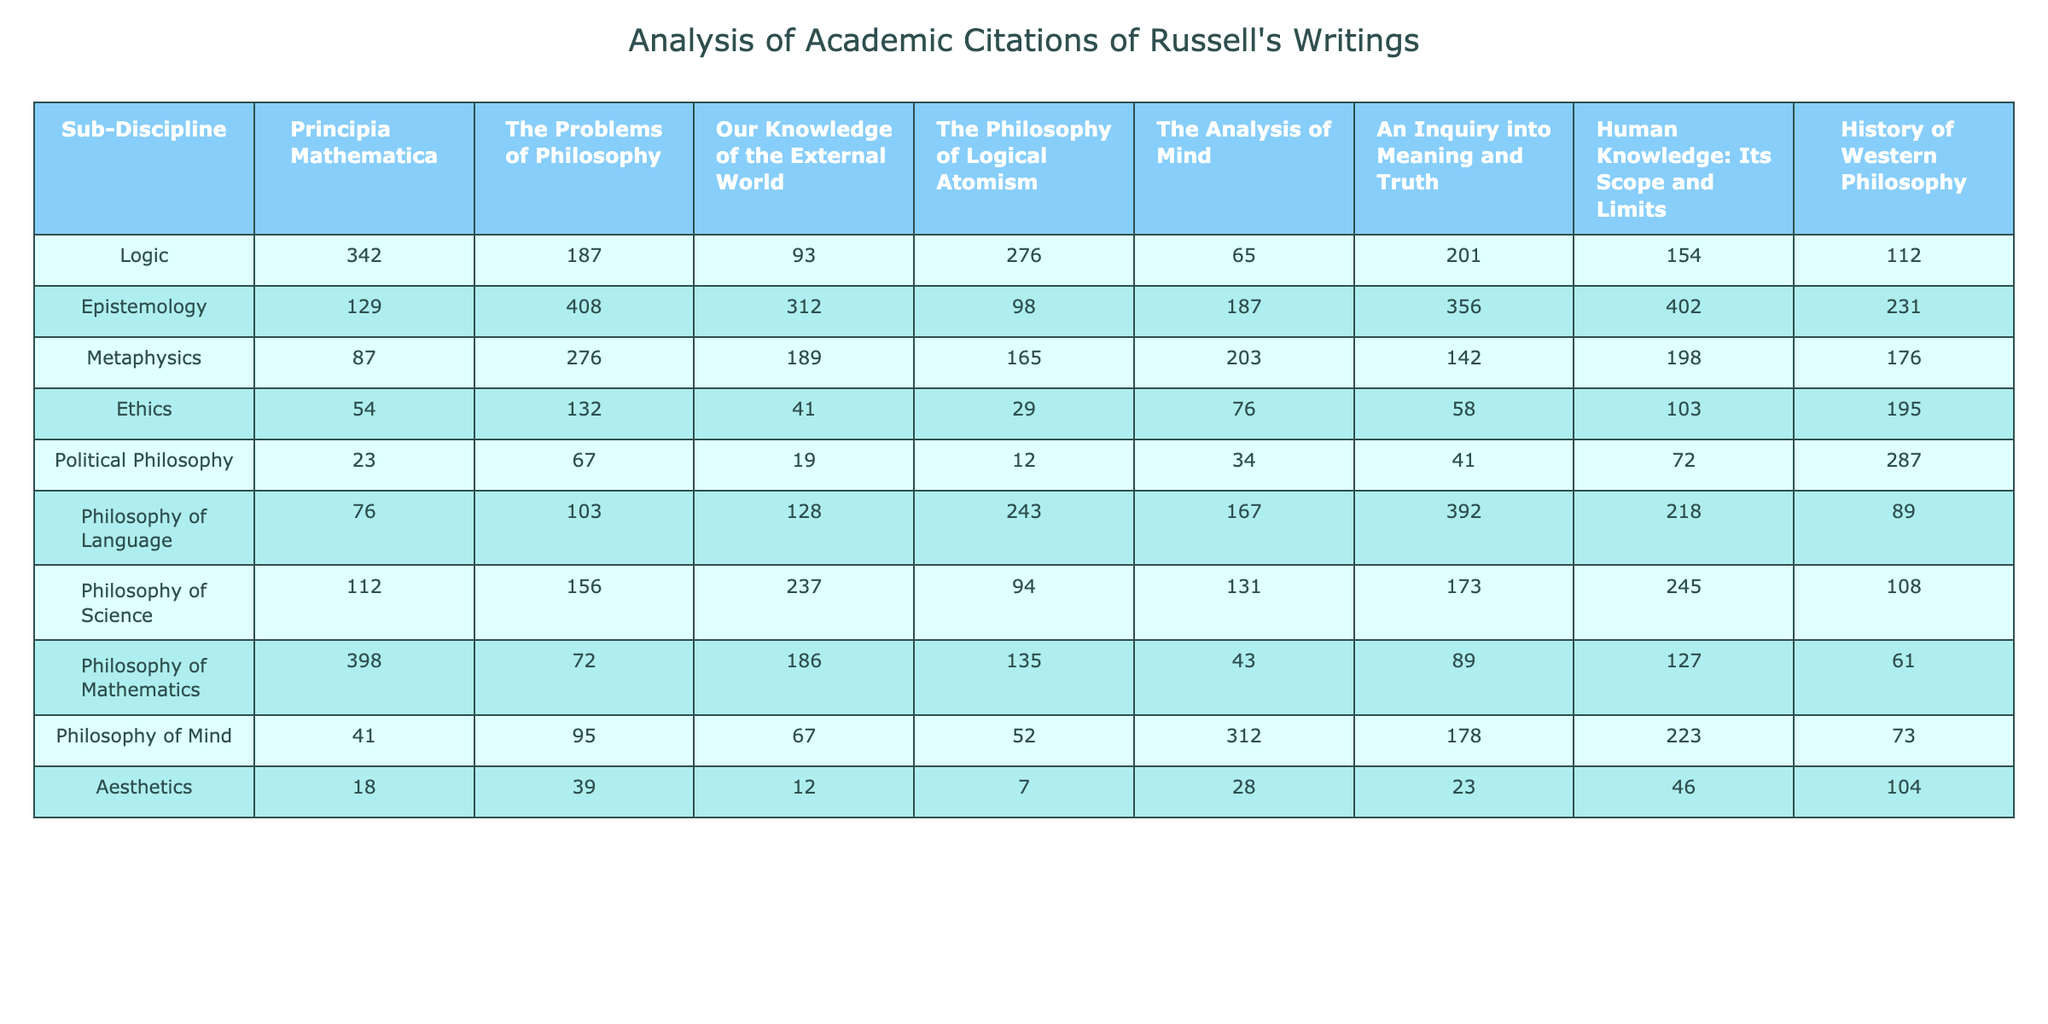What is the highest number of citations for "Principia Mathematica" across all sub-disciplines? The highest citation count for "Principia Mathematica" is found in the Philosophy of Mathematics sub-discipline with a total of 398 citations.
Answer: 398 Which sub-discipline has the least number of citations for "The Problems of Philosophy"? By examining the table, the sub-discipline with the least citations for "The Problems of Philosophy" is Aesthetics, which has 39 citations.
Answer: 39 What is the total number of citations for "The Analysis of Mind" across all sub-disciplines? To find the total citations for "The Analysis of Mind," we sum the citations across all sub-disciplines: 65 + 187 + 203 + 76 + 34 + 167 + 312 + 28 = 1,072.
Answer: 1072 Which sub-discipline has more citations for "Human Knowledge: Its Scope and Limits" than for "Ethics"? In the table, "Human Knowledge: Its Scope and Limits" has 154 citations in Logic, 402 in Epistemology, 198 in Metaphysics, 103 in Ethics, 72 in Political Philosophy, 218 in Philosophy of Language, 245 in Philosophy of Science, 127 in Philosophy of Mathematics, 223 in Philosophy of Mind, and 46 in Aesthetics. Almost all related sub-disciplines have more than the Ethics citations of 195, with the exception of Political Philosophy (72) and Aesthetics (46). Therefore, all other sub-disciplines exceed Ethics.
Answer: Yes What is the average number of citations for "Our Knowledge of the External World" across all sub-disciplines? The total citations for "Our Knowledge of the External World" is 93 + 312 + 189 + 41 + 19 + 128 + 237 + 186 + 67 + 12 = 1,575. There are 10 sub-disciplines, so the average is 1,575 divided by 10, which equals 157.5.
Answer: 157.5 In which sub-discipline does "The Problems of Philosophy" have more citations than "Logic"? For "The Problems of Philosophy," we check all sub-disciplines: it has 187 in Logic, 408 in Epistemology, 276 in Metaphysics, 132 in Ethics, 67 in Political Philosophy, 103 in Philosophy of Language, 156 in Philosophy of Science, 72 in Philosophy of Mathematics, 95 in Philosophy of Mind, and 39 in Aesthetics. The sub-disciplines where it exceeds Logic's 187 are Epistemology, Metaphysics, Ethics, Philosophy of Language, and Philosophy of Science.
Answer: Yes What is the difference in citation counts between "Philosophy of Language" and "History of Western Philosophy"? The citation count for "Philosophy of Language" is 392, and for "History of Western Philosophy," it is 89. Therefore, the difference is calculated as 392 - 89 = 303.
Answer: 303 